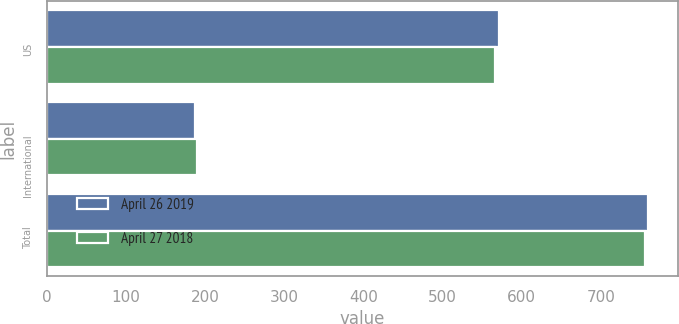<chart> <loc_0><loc_0><loc_500><loc_500><stacked_bar_chart><ecel><fcel>US<fcel>International<fcel>Total<nl><fcel>April 26 2019<fcel>572<fcel>187<fcel>759<nl><fcel>April 27 2018<fcel>566<fcel>190<fcel>756<nl></chart> 